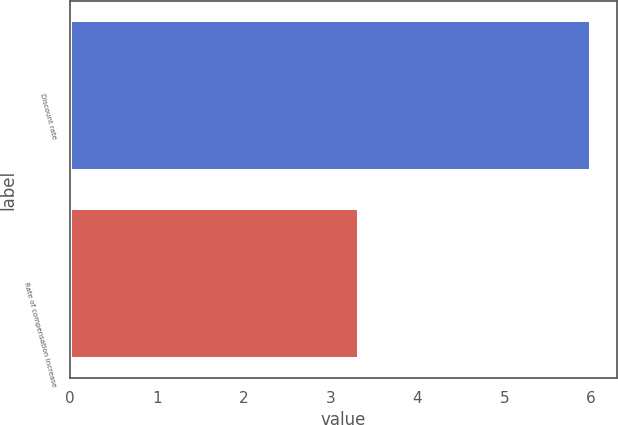<chart> <loc_0><loc_0><loc_500><loc_500><bar_chart><fcel>Discount rate<fcel>Rate of compensation increase<nl><fcel>6<fcel>3.33<nl></chart> 